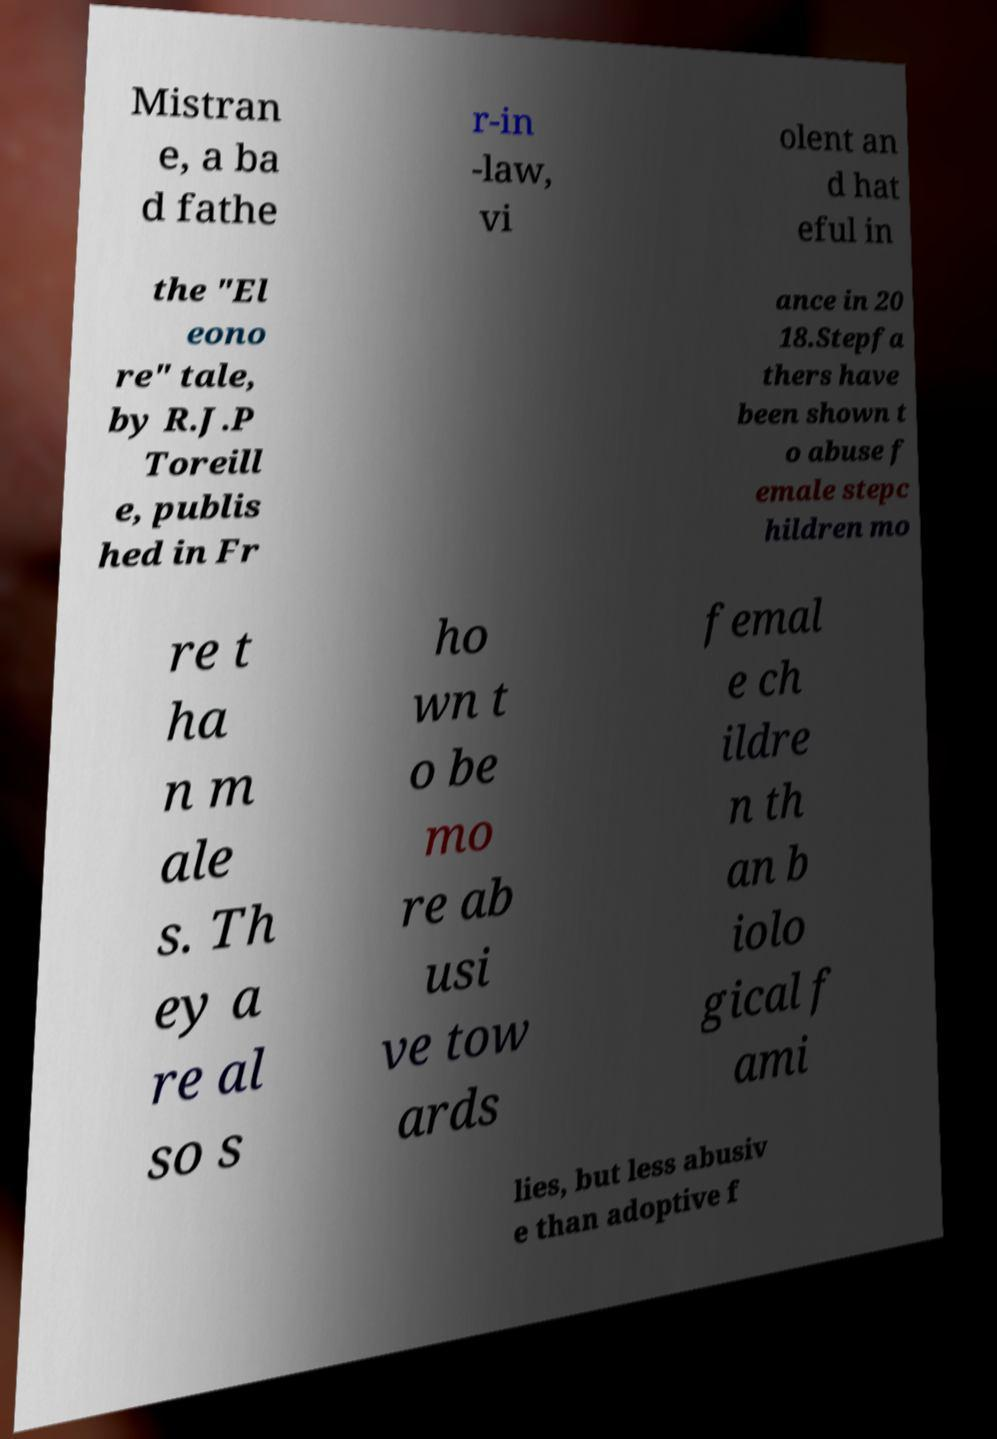Could you assist in decoding the text presented in this image and type it out clearly? Mistran e, a ba d fathe r-in -law, vi olent an d hat eful in the "El eono re" tale, by R.J.P Toreill e, publis hed in Fr ance in 20 18.Stepfa thers have been shown t o abuse f emale stepc hildren mo re t ha n m ale s. Th ey a re al so s ho wn t o be mo re ab usi ve tow ards femal e ch ildre n th an b iolo gical f ami lies, but less abusiv e than adoptive f 